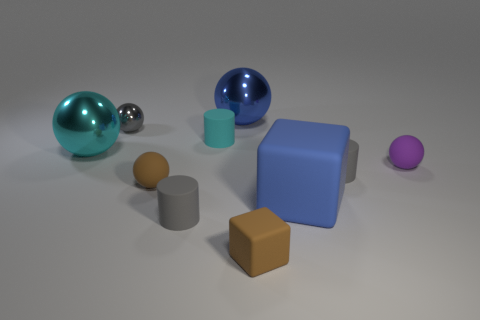Do the cyan shiny thing and the cyan cylinder have the same size?
Your answer should be compact. No. What is the material of the cyan cylinder?
Offer a very short reply. Rubber. There is a blue block that is the same size as the blue metallic thing; what is it made of?
Your answer should be very brief. Rubber. Are there any red shiny balls that have the same size as the blue metal sphere?
Your answer should be compact. No. Is the number of big cubes that are on the left side of the big cyan thing the same as the number of small cylinders that are behind the gray sphere?
Your response must be concise. Yes. Are there more big red matte things than small purple rubber objects?
Offer a very short reply. No. What number of matte objects are balls or large gray blocks?
Offer a very short reply. 2. What number of small things have the same color as the tiny rubber block?
Your response must be concise. 1. The blue object that is in front of the cyan thing to the left of the rubber cylinder that is in front of the blue matte thing is made of what material?
Provide a short and direct response. Rubber. What is the color of the small rubber sphere that is left of the shiny thing that is on the right side of the small gray metallic sphere?
Give a very brief answer. Brown. 